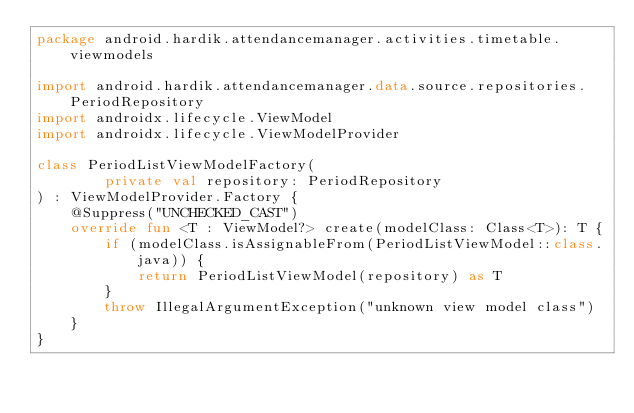<code> <loc_0><loc_0><loc_500><loc_500><_Kotlin_>package android.hardik.attendancemanager.activities.timetable.viewmodels

import android.hardik.attendancemanager.data.source.repositories.PeriodRepository
import androidx.lifecycle.ViewModel
import androidx.lifecycle.ViewModelProvider

class PeriodListViewModelFactory(
        private val repository: PeriodRepository
) : ViewModelProvider.Factory {
    @Suppress("UNCHECKED_CAST")
    override fun <T : ViewModel?> create(modelClass: Class<T>): T {
        if (modelClass.isAssignableFrom(PeriodListViewModel::class.java)) {
            return PeriodListViewModel(repository) as T
        }
        throw IllegalArgumentException("unknown view model class")
    }
}</code> 